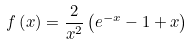<formula> <loc_0><loc_0><loc_500><loc_500>f \left ( x \right ) = \frac { 2 } { x ^ { 2 } } \left ( e ^ { - x } - 1 + x \right )</formula> 